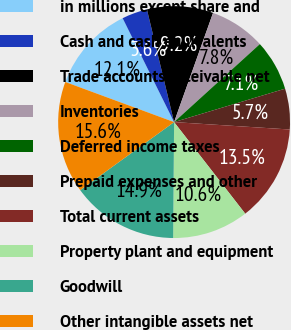Convert chart. <chart><loc_0><loc_0><loc_500><loc_500><pie_chart><fcel>in millions except share and<fcel>Cash and cash equivalents<fcel>Trade accounts receivable net<fcel>Inventories<fcel>Deferred income taxes<fcel>Prepaid expenses and other<fcel>Total current assets<fcel>Property plant and equipment<fcel>Goodwill<fcel>Other intangible assets net<nl><fcel>12.06%<fcel>3.55%<fcel>9.22%<fcel>7.8%<fcel>7.09%<fcel>5.67%<fcel>13.47%<fcel>10.64%<fcel>14.89%<fcel>15.6%<nl></chart> 